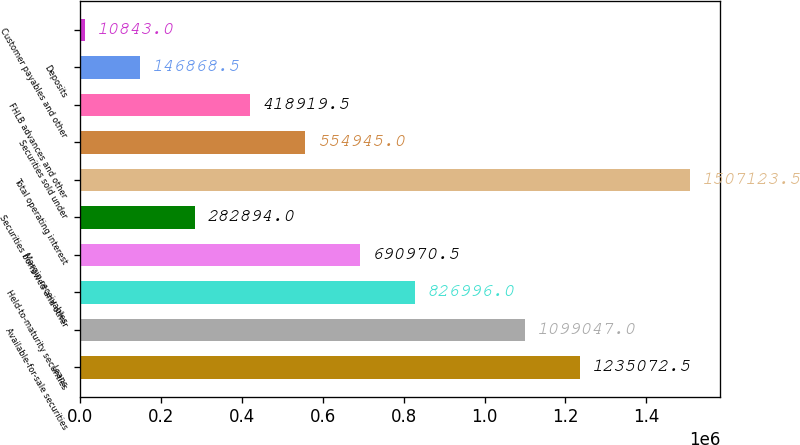Convert chart. <chart><loc_0><loc_0><loc_500><loc_500><bar_chart><fcel>Loans<fcel>Available-for-sale securities<fcel>Held-to-maturity securities<fcel>Margin receivables<fcel>Securities borrowed and other<fcel>Total operating interest<fcel>Securities sold under<fcel>FHLB advances and other<fcel>Deposits<fcel>Customer payables and other<nl><fcel>1.23507e+06<fcel>1.09905e+06<fcel>826996<fcel>690970<fcel>282894<fcel>1.50712e+06<fcel>554945<fcel>418920<fcel>146868<fcel>10843<nl></chart> 